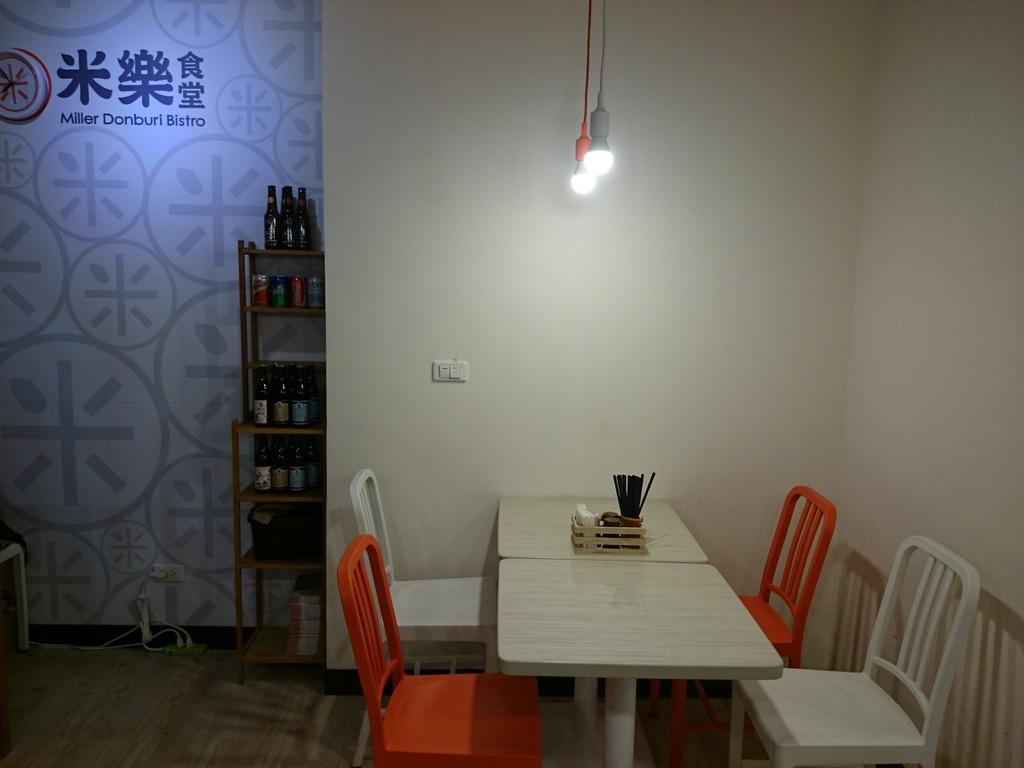Could you give a brief overview of what you see in this image? In the image we can see four chairs, two orange and two white in color. Here we can see table, on the table there is an object. Here we can see shelf and on the shelf there are bottles. Here we can see light , switchboard, floor, cable wire, wall and text. 